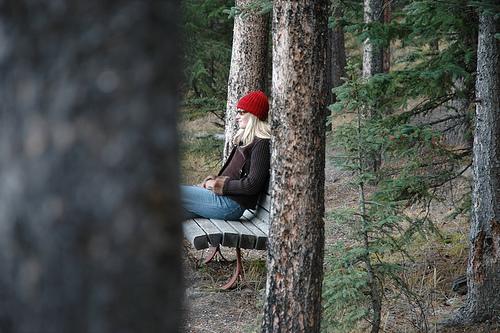Are the woman's lower legs visible?
Give a very brief answer. No. Does she appear to be happy?
Concise answer only. Yes. Where is she sitting?
Quick response, please. Bench. Is she working or playing?
Concise answer only. Playing. What color hat is this person wearing?
Short answer required. Red. 